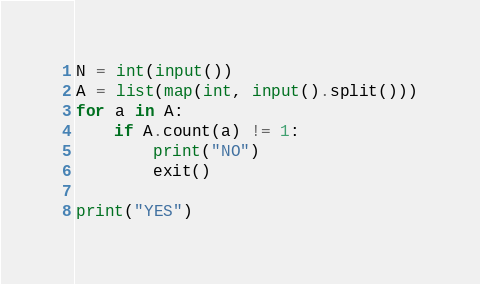<code> <loc_0><loc_0><loc_500><loc_500><_Python_>N = int(input())
A = list(map(int, input().split()))
for a in A:
    if A.count(a) != 1:
        print("NO")
        exit()

print("YES")</code> 